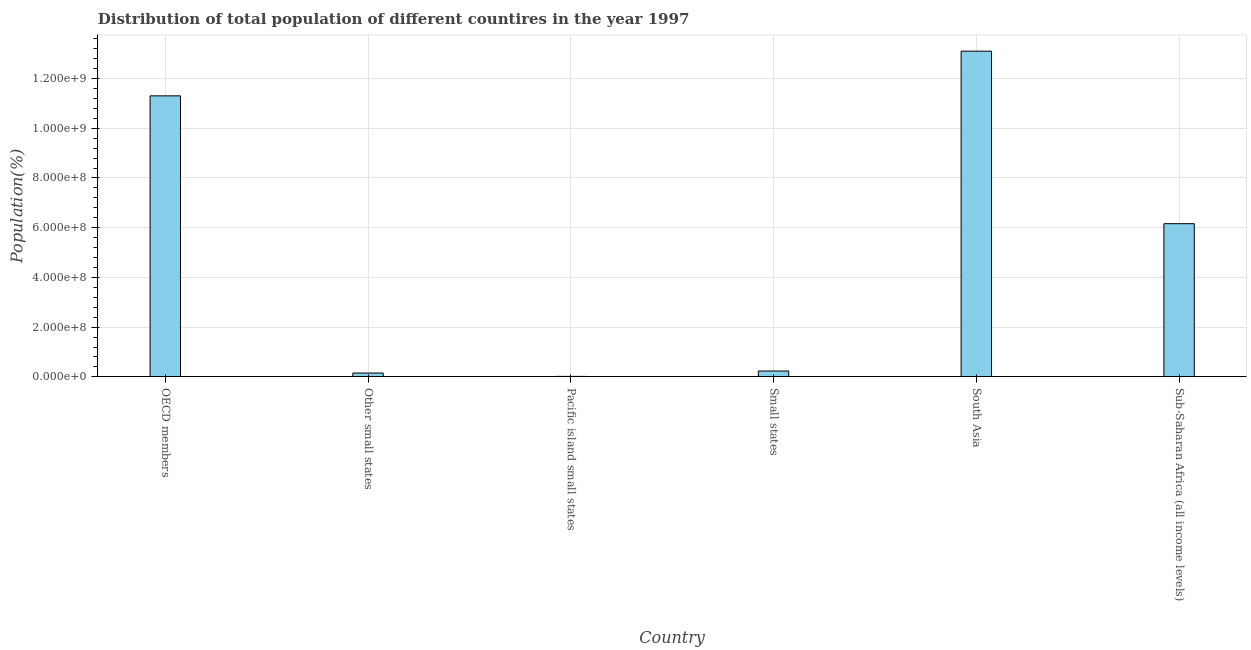What is the title of the graph?
Offer a terse response. Distribution of total population of different countires in the year 1997. What is the label or title of the Y-axis?
Keep it short and to the point. Population(%). What is the population in Pacific island small states?
Give a very brief answer. 1.88e+06. Across all countries, what is the maximum population?
Your answer should be compact. 1.31e+09. Across all countries, what is the minimum population?
Provide a short and direct response. 1.88e+06. In which country was the population maximum?
Ensure brevity in your answer.  South Asia. In which country was the population minimum?
Offer a very short reply. Pacific island small states. What is the sum of the population?
Your response must be concise. 3.10e+09. What is the difference between the population in OECD members and Other small states?
Make the answer very short. 1.11e+09. What is the average population per country?
Ensure brevity in your answer.  5.16e+08. What is the median population?
Make the answer very short. 3.20e+08. In how many countries, is the population greater than 360000000 %?
Offer a very short reply. 3. What is the ratio of the population in Pacific island small states to that in Sub-Saharan Africa (all income levels)?
Provide a succinct answer. 0. Is the population in Other small states less than that in Pacific island small states?
Make the answer very short. No. Is the difference between the population in Other small states and Small states greater than the difference between any two countries?
Make the answer very short. No. What is the difference between the highest and the second highest population?
Make the answer very short. 1.80e+08. What is the difference between the highest and the lowest population?
Your answer should be very brief. 1.31e+09. In how many countries, is the population greater than the average population taken over all countries?
Your answer should be very brief. 3. Are all the bars in the graph horizontal?
Your response must be concise. No. What is the difference between two consecutive major ticks on the Y-axis?
Keep it short and to the point. 2.00e+08. Are the values on the major ticks of Y-axis written in scientific E-notation?
Your answer should be compact. Yes. What is the Population(%) in OECD members?
Keep it short and to the point. 1.13e+09. What is the Population(%) of Other small states?
Offer a terse response. 1.54e+07. What is the Population(%) in Pacific island small states?
Your answer should be compact. 1.88e+06. What is the Population(%) of Small states?
Ensure brevity in your answer.  2.36e+07. What is the Population(%) in South Asia?
Offer a very short reply. 1.31e+09. What is the Population(%) of Sub-Saharan Africa (all income levels)?
Provide a succinct answer. 6.16e+08. What is the difference between the Population(%) in OECD members and Other small states?
Provide a short and direct response. 1.11e+09. What is the difference between the Population(%) in OECD members and Pacific island small states?
Provide a short and direct response. 1.13e+09. What is the difference between the Population(%) in OECD members and Small states?
Make the answer very short. 1.11e+09. What is the difference between the Population(%) in OECD members and South Asia?
Your response must be concise. -1.80e+08. What is the difference between the Population(%) in OECD members and Sub-Saharan Africa (all income levels)?
Provide a short and direct response. 5.14e+08. What is the difference between the Population(%) in Other small states and Pacific island small states?
Provide a short and direct response. 1.35e+07. What is the difference between the Population(%) in Other small states and Small states?
Keep it short and to the point. -8.20e+06. What is the difference between the Population(%) in Other small states and South Asia?
Offer a terse response. -1.29e+09. What is the difference between the Population(%) in Other small states and Sub-Saharan Africa (all income levels)?
Offer a very short reply. -6.01e+08. What is the difference between the Population(%) in Pacific island small states and Small states?
Your response must be concise. -2.17e+07. What is the difference between the Population(%) in Pacific island small states and South Asia?
Offer a terse response. -1.31e+09. What is the difference between the Population(%) in Pacific island small states and Sub-Saharan Africa (all income levels)?
Provide a short and direct response. -6.14e+08. What is the difference between the Population(%) in Small states and South Asia?
Keep it short and to the point. -1.29e+09. What is the difference between the Population(%) in Small states and Sub-Saharan Africa (all income levels)?
Your answer should be compact. -5.93e+08. What is the difference between the Population(%) in South Asia and Sub-Saharan Africa (all income levels)?
Provide a short and direct response. 6.94e+08. What is the ratio of the Population(%) in OECD members to that in Other small states?
Ensure brevity in your answer.  73.4. What is the ratio of the Population(%) in OECD members to that in Pacific island small states?
Provide a succinct answer. 599.86. What is the ratio of the Population(%) in OECD members to that in Small states?
Your response must be concise. 47.9. What is the ratio of the Population(%) in OECD members to that in South Asia?
Provide a short and direct response. 0.86. What is the ratio of the Population(%) in OECD members to that in Sub-Saharan Africa (all income levels)?
Ensure brevity in your answer.  1.83. What is the ratio of the Population(%) in Other small states to that in Pacific island small states?
Offer a terse response. 8.17. What is the ratio of the Population(%) in Other small states to that in Small states?
Keep it short and to the point. 0.65. What is the ratio of the Population(%) in Other small states to that in South Asia?
Make the answer very short. 0.01. What is the ratio of the Population(%) in Other small states to that in Sub-Saharan Africa (all income levels)?
Keep it short and to the point. 0.03. What is the ratio of the Population(%) in Pacific island small states to that in Small states?
Offer a terse response. 0.08. What is the ratio of the Population(%) in Pacific island small states to that in South Asia?
Ensure brevity in your answer.  0. What is the ratio of the Population(%) in Pacific island small states to that in Sub-Saharan Africa (all income levels)?
Your answer should be compact. 0. What is the ratio of the Population(%) in Small states to that in South Asia?
Provide a succinct answer. 0.02. What is the ratio of the Population(%) in Small states to that in Sub-Saharan Africa (all income levels)?
Offer a very short reply. 0.04. What is the ratio of the Population(%) in South Asia to that in Sub-Saharan Africa (all income levels)?
Offer a terse response. 2.13. 